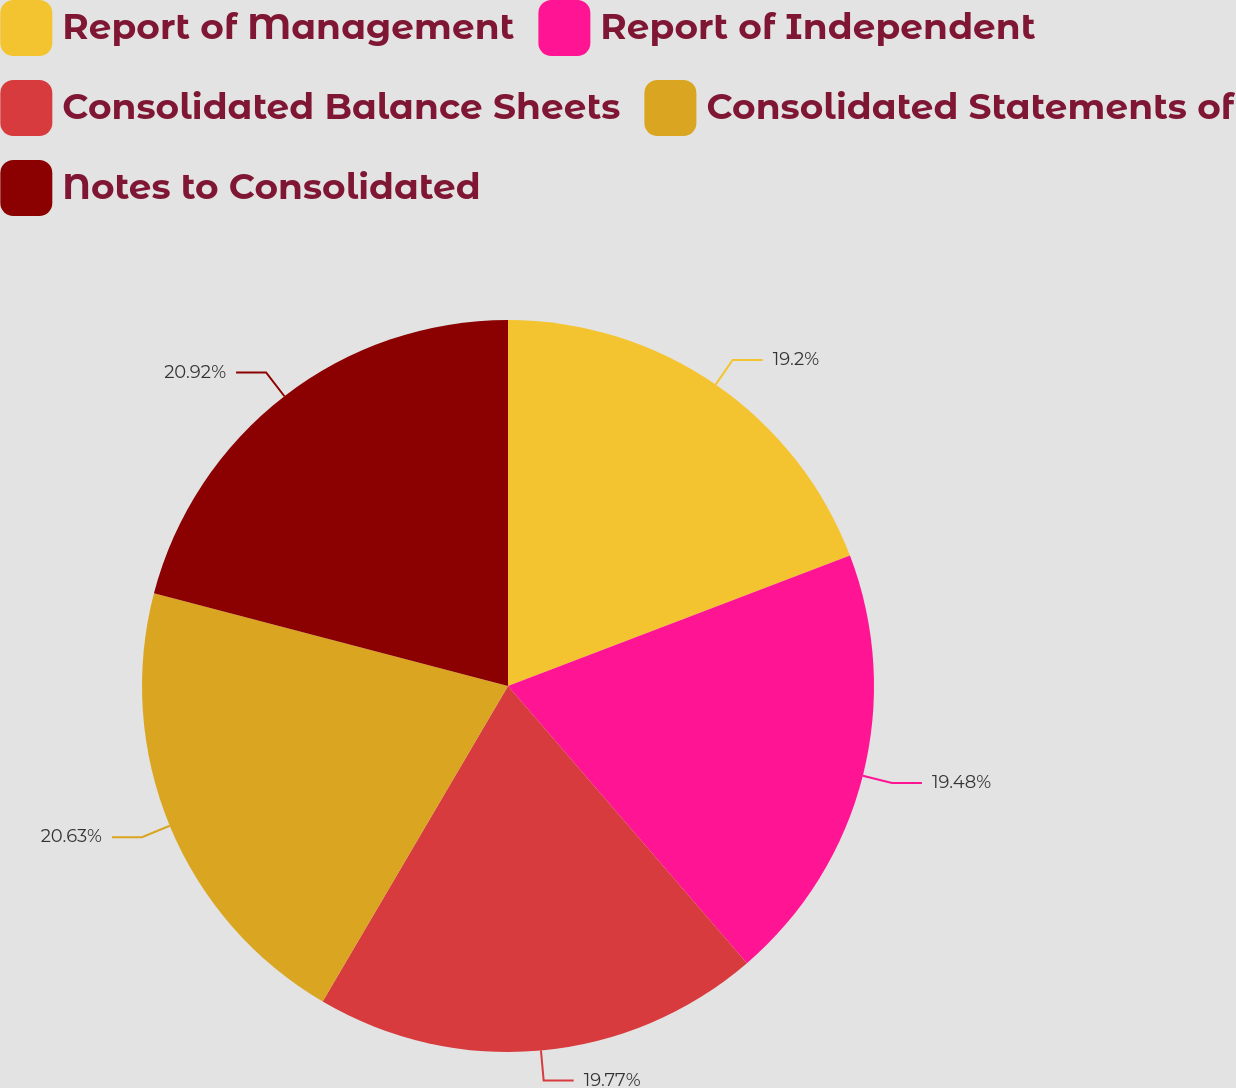Convert chart to OTSL. <chart><loc_0><loc_0><loc_500><loc_500><pie_chart><fcel>Report of Management<fcel>Report of Independent<fcel>Consolidated Balance Sheets<fcel>Consolidated Statements of<fcel>Notes to Consolidated<nl><fcel>19.2%<fcel>19.48%<fcel>19.77%<fcel>20.63%<fcel>20.92%<nl></chart> 